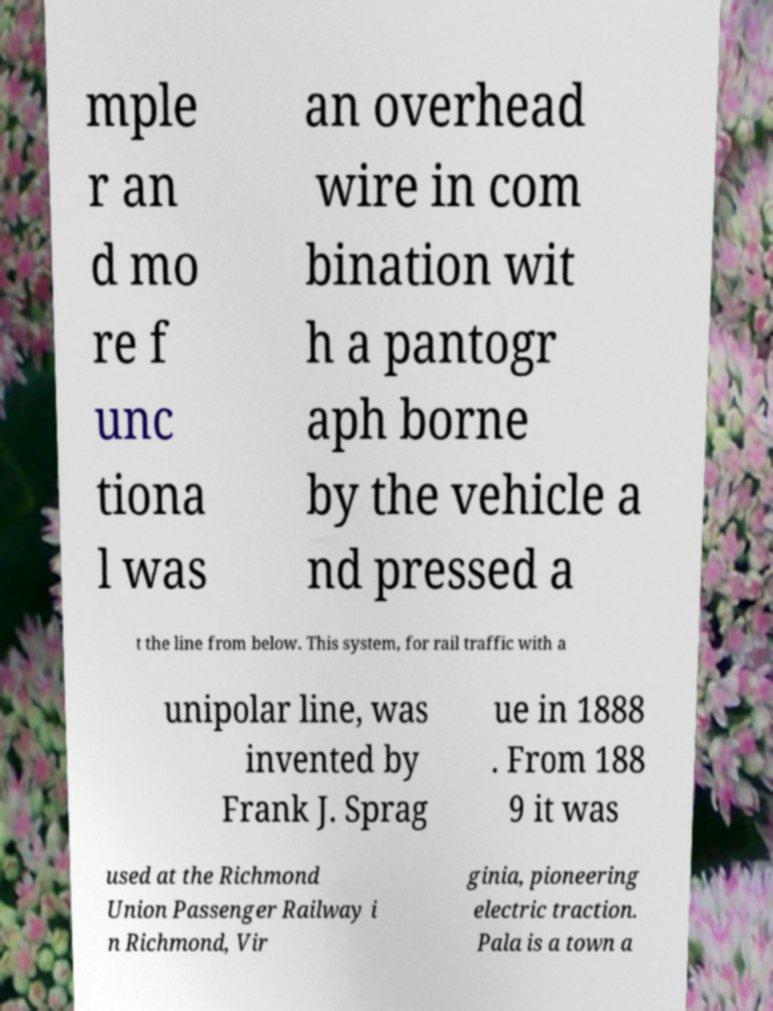Could you assist in decoding the text presented in this image and type it out clearly? mple r an d mo re f unc tiona l was an overhead wire in com bination wit h a pantogr aph borne by the vehicle a nd pressed a t the line from below. This system, for rail traffic with a unipolar line, was invented by Frank J. Sprag ue in 1888 . From 188 9 it was used at the Richmond Union Passenger Railway i n Richmond, Vir ginia, pioneering electric traction. Pala is a town a 